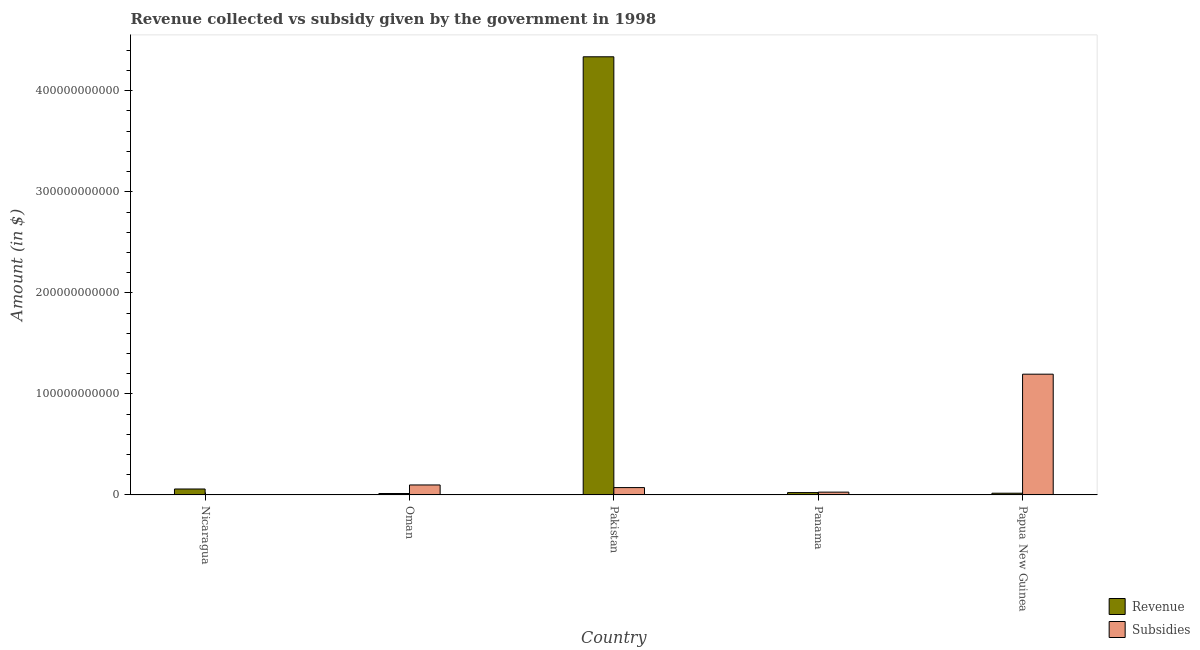How many different coloured bars are there?
Make the answer very short. 2. How many groups of bars are there?
Your response must be concise. 5. Are the number of bars on each tick of the X-axis equal?
Your response must be concise. Yes. How many bars are there on the 1st tick from the right?
Ensure brevity in your answer.  2. What is the label of the 4th group of bars from the left?
Your answer should be compact. Panama. In how many cases, is the number of bars for a given country not equal to the number of legend labels?
Your answer should be very brief. 0. What is the amount of subsidies given in Panama?
Ensure brevity in your answer.  2.77e+09. Across all countries, what is the maximum amount of subsidies given?
Provide a succinct answer. 1.20e+11. Across all countries, what is the minimum amount of revenue collected?
Ensure brevity in your answer.  1.41e+09. In which country was the amount of subsidies given maximum?
Your answer should be very brief. Papua New Guinea. In which country was the amount of subsidies given minimum?
Provide a short and direct response. Nicaragua. What is the total amount of revenue collected in the graph?
Your answer should be compact. 4.45e+11. What is the difference between the amount of subsidies given in Pakistan and that in Panama?
Provide a short and direct response. 4.51e+09. What is the difference between the amount of subsidies given in Nicaragua and the amount of revenue collected in Pakistan?
Offer a terse response. -4.33e+11. What is the average amount of subsidies given per country?
Keep it short and to the point. 2.80e+1. What is the difference between the amount of subsidies given and amount of revenue collected in Papua New Guinea?
Your answer should be compact. 1.18e+11. What is the ratio of the amount of revenue collected in Panama to that in Papua New Guinea?
Give a very brief answer. 1.37. Is the difference between the amount of revenue collected in Nicaragua and Panama greater than the difference between the amount of subsidies given in Nicaragua and Panama?
Your answer should be very brief. Yes. What is the difference between the highest and the second highest amount of subsidies given?
Your answer should be very brief. 1.10e+11. What is the difference between the highest and the lowest amount of revenue collected?
Your answer should be very brief. 4.32e+11. Is the sum of the amount of subsidies given in Panama and Papua New Guinea greater than the maximum amount of revenue collected across all countries?
Give a very brief answer. No. What does the 2nd bar from the left in Oman represents?
Offer a terse response. Subsidies. What does the 2nd bar from the right in Oman represents?
Make the answer very short. Revenue. How many countries are there in the graph?
Give a very brief answer. 5. What is the difference between two consecutive major ticks on the Y-axis?
Make the answer very short. 1.00e+11. Are the values on the major ticks of Y-axis written in scientific E-notation?
Keep it short and to the point. No. How many legend labels are there?
Offer a very short reply. 2. How are the legend labels stacked?
Ensure brevity in your answer.  Vertical. What is the title of the graph?
Keep it short and to the point. Revenue collected vs subsidy given by the government in 1998. Does "Female" appear as one of the legend labels in the graph?
Keep it short and to the point. No. What is the label or title of the Y-axis?
Your response must be concise. Amount (in $). What is the Amount (in $) of Revenue in Nicaragua?
Give a very brief answer. 5.89e+09. What is the Amount (in $) in Subsidies in Nicaragua?
Provide a short and direct response. 3.72e+08. What is the Amount (in $) in Revenue in Oman?
Your response must be concise. 1.41e+09. What is the Amount (in $) in Subsidies in Oman?
Make the answer very short. 9.87e+09. What is the Amount (in $) in Revenue in Pakistan?
Your response must be concise. 4.34e+11. What is the Amount (in $) in Subsidies in Pakistan?
Your answer should be very brief. 7.28e+09. What is the Amount (in $) in Revenue in Panama?
Provide a short and direct response. 2.33e+09. What is the Amount (in $) of Subsidies in Panama?
Offer a very short reply. 2.77e+09. What is the Amount (in $) of Revenue in Papua New Guinea?
Make the answer very short. 1.70e+09. What is the Amount (in $) in Subsidies in Papua New Guinea?
Your answer should be very brief. 1.20e+11. Across all countries, what is the maximum Amount (in $) of Revenue?
Offer a very short reply. 4.34e+11. Across all countries, what is the maximum Amount (in $) of Subsidies?
Your response must be concise. 1.20e+11. Across all countries, what is the minimum Amount (in $) of Revenue?
Offer a terse response. 1.41e+09. Across all countries, what is the minimum Amount (in $) in Subsidies?
Offer a very short reply. 3.72e+08. What is the total Amount (in $) of Revenue in the graph?
Ensure brevity in your answer.  4.45e+11. What is the total Amount (in $) in Subsidies in the graph?
Keep it short and to the point. 1.40e+11. What is the difference between the Amount (in $) of Revenue in Nicaragua and that in Oman?
Keep it short and to the point. 4.47e+09. What is the difference between the Amount (in $) in Subsidies in Nicaragua and that in Oman?
Make the answer very short. -9.50e+09. What is the difference between the Amount (in $) in Revenue in Nicaragua and that in Pakistan?
Keep it short and to the point. -4.28e+11. What is the difference between the Amount (in $) in Subsidies in Nicaragua and that in Pakistan?
Offer a terse response. -6.91e+09. What is the difference between the Amount (in $) of Revenue in Nicaragua and that in Panama?
Your answer should be compact. 3.56e+09. What is the difference between the Amount (in $) in Subsidies in Nicaragua and that in Panama?
Offer a terse response. -2.40e+09. What is the difference between the Amount (in $) in Revenue in Nicaragua and that in Papua New Guinea?
Give a very brief answer. 4.18e+09. What is the difference between the Amount (in $) of Subsidies in Nicaragua and that in Papua New Guinea?
Provide a short and direct response. -1.19e+11. What is the difference between the Amount (in $) in Revenue in Oman and that in Pakistan?
Your answer should be compact. -4.32e+11. What is the difference between the Amount (in $) of Subsidies in Oman and that in Pakistan?
Provide a succinct answer. 2.60e+09. What is the difference between the Amount (in $) of Revenue in Oman and that in Panama?
Provide a succinct answer. -9.15e+08. What is the difference between the Amount (in $) in Subsidies in Oman and that in Panama?
Offer a very short reply. 7.10e+09. What is the difference between the Amount (in $) in Revenue in Oman and that in Papua New Guinea?
Offer a very short reply. -2.89e+08. What is the difference between the Amount (in $) of Subsidies in Oman and that in Papua New Guinea?
Keep it short and to the point. -1.10e+11. What is the difference between the Amount (in $) in Revenue in Pakistan and that in Panama?
Provide a succinct answer. 4.31e+11. What is the difference between the Amount (in $) of Subsidies in Pakistan and that in Panama?
Offer a terse response. 4.51e+09. What is the difference between the Amount (in $) in Revenue in Pakistan and that in Papua New Guinea?
Offer a terse response. 4.32e+11. What is the difference between the Amount (in $) in Subsidies in Pakistan and that in Papua New Guinea?
Your answer should be very brief. -1.12e+11. What is the difference between the Amount (in $) of Revenue in Panama and that in Papua New Guinea?
Provide a succinct answer. 6.26e+08. What is the difference between the Amount (in $) in Subsidies in Panama and that in Papua New Guinea?
Ensure brevity in your answer.  -1.17e+11. What is the difference between the Amount (in $) in Revenue in Nicaragua and the Amount (in $) in Subsidies in Oman?
Your answer should be very brief. -3.99e+09. What is the difference between the Amount (in $) in Revenue in Nicaragua and the Amount (in $) in Subsidies in Pakistan?
Provide a succinct answer. -1.39e+09. What is the difference between the Amount (in $) in Revenue in Nicaragua and the Amount (in $) in Subsidies in Panama?
Ensure brevity in your answer.  3.12e+09. What is the difference between the Amount (in $) of Revenue in Nicaragua and the Amount (in $) of Subsidies in Papua New Guinea?
Keep it short and to the point. -1.14e+11. What is the difference between the Amount (in $) of Revenue in Oman and the Amount (in $) of Subsidies in Pakistan?
Offer a terse response. -5.86e+09. What is the difference between the Amount (in $) of Revenue in Oman and the Amount (in $) of Subsidies in Panama?
Keep it short and to the point. -1.36e+09. What is the difference between the Amount (in $) of Revenue in Oman and the Amount (in $) of Subsidies in Papua New Guinea?
Your response must be concise. -1.18e+11. What is the difference between the Amount (in $) in Revenue in Pakistan and the Amount (in $) in Subsidies in Panama?
Keep it short and to the point. 4.31e+11. What is the difference between the Amount (in $) of Revenue in Pakistan and the Amount (in $) of Subsidies in Papua New Guinea?
Ensure brevity in your answer.  3.14e+11. What is the difference between the Amount (in $) in Revenue in Panama and the Amount (in $) in Subsidies in Papua New Guinea?
Provide a short and direct response. -1.17e+11. What is the average Amount (in $) of Revenue per country?
Your answer should be very brief. 8.90e+1. What is the average Amount (in $) in Subsidies per country?
Make the answer very short. 2.80e+1. What is the difference between the Amount (in $) of Revenue and Amount (in $) of Subsidies in Nicaragua?
Provide a succinct answer. 5.51e+09. What is the difference between the Amount (in $) in Revenue and Amount (in $) in Subsidies in Oman?
Give a very brief answer. -8.46e+09. What is the difference between the Amount (in $) in Revenue and Amount (in $) in Subsidies in Pakistan?
Make the answer very short. 4.26e+11. What is the difference between the Amount (in $) of Revenue and Amount (in $) of Subsidies in Panama?
Your answer should be very brief. -4.41e+08. What is the difference between the Amount (in $) in Revenue and Amount (in $) in Subsidies in Papua New Guinea?
Keep it short and to the point. -1.18e+11. What is the ratio of the Amount (in $) in Revenue in Nicaragua to that in Oman?
Offer a very short reply. 4.16. What is the ratio of the Amount (in $) of Subsidies in Nicaragua to that in Oman?
Provide a short and direct response. 0.04. What is the ratio of the Amount (in $) of Revenue in Nicaragua to that in Pakistan?
Your answer should be very brief. 0.01. What is the ratio of the Amount (in $) of Subsidies in Nicaragua to that in Pakistan?
Your answer should be very brief. 0.05. What is the ratio of the Amount (in $) in Revenue in Nicaragua to that in Panama?
Provide a succinct answer. 2.53. What is the ratio of the Amount (in $) in Subsidies in Nicaragua to that in Panama?
Ensure brevity in your answer.  0.13. What is the ratio of the Amount (in $) of Revenue in Nicaragua to that in Papua New Guinea?
Your answer should be compact. 3.45. What is the ratio of the Amount (in $) in Subsidies in Nicaragua to that in Papua New Guinea?
Your answer should be compact. 0. What is the ratio of the Amount (in $) in Revenue in Oman to that in Pakistan?
Keep it short and to the point. 0. What is the ratio of the Amount (in $) in Subsidies in Oman to that in Pakistan?
Make the answer very short. 1.36. What is the ratio of the Amount (in $) of Revenue in Oman to that in Panama?
Offer a very short reply. 0.61. What is the ratio of the Amount (in $) of Subsidies in Oman to that in Panama?
Offer a terse response. 3.56. What is the ratio of the Amount (in $) of Revenue in Oman to that in Papua New Guinea?
Offer a terse response. 0.83. What is the ratio of the Amount (in $) in Subsidies in Oman to that in Papua New Guinea?
Provide a succinct answer. 0.08. What is the ratio of the Amount (in $) in Revenue in Pakistan to that in Panama?
Offer a terse response. 186.13. What is the ratio of the Amount (in $) in Subsidies in Pakistan to that in Panama?
Offer a terse response. 2.63. What is the ratio of the Amount (in $) in Revenue in Pakistan to that in Papua New Guinea?
Make the answer very short. 254.51. What is the ratio of the Amount (in $) of Subsidies in Pakistan to that in Papua New Guinea?
Offer a very short reply. 0.06. What is the ratio of the Amount (in $) in Revenue in Panama to that in Papua New Guinea?
Make the answer very short. 1.37. What is the ratio of the Amount (in $) in Subsidies in Panama to that in Papua New Guinea?
Make the answer very short. 0.02. What is the difference between the highest and the second highest Amount (in $) in Revenue?
Provide a succinct answer. 4.28e+11. What is the difference between the highest and the second highest Amount (in $) in Subsidies?
Your answer should be very brief. 1.10e+11. What is the difference between the highest and the lowest Amount (in $) in Revenue?
Give a very brief answer. 4.32e+11. What is the difference between the highest and the lowest Amount (in $) in Subsidies?
Provide a succinct answer. 1.19e+11. 